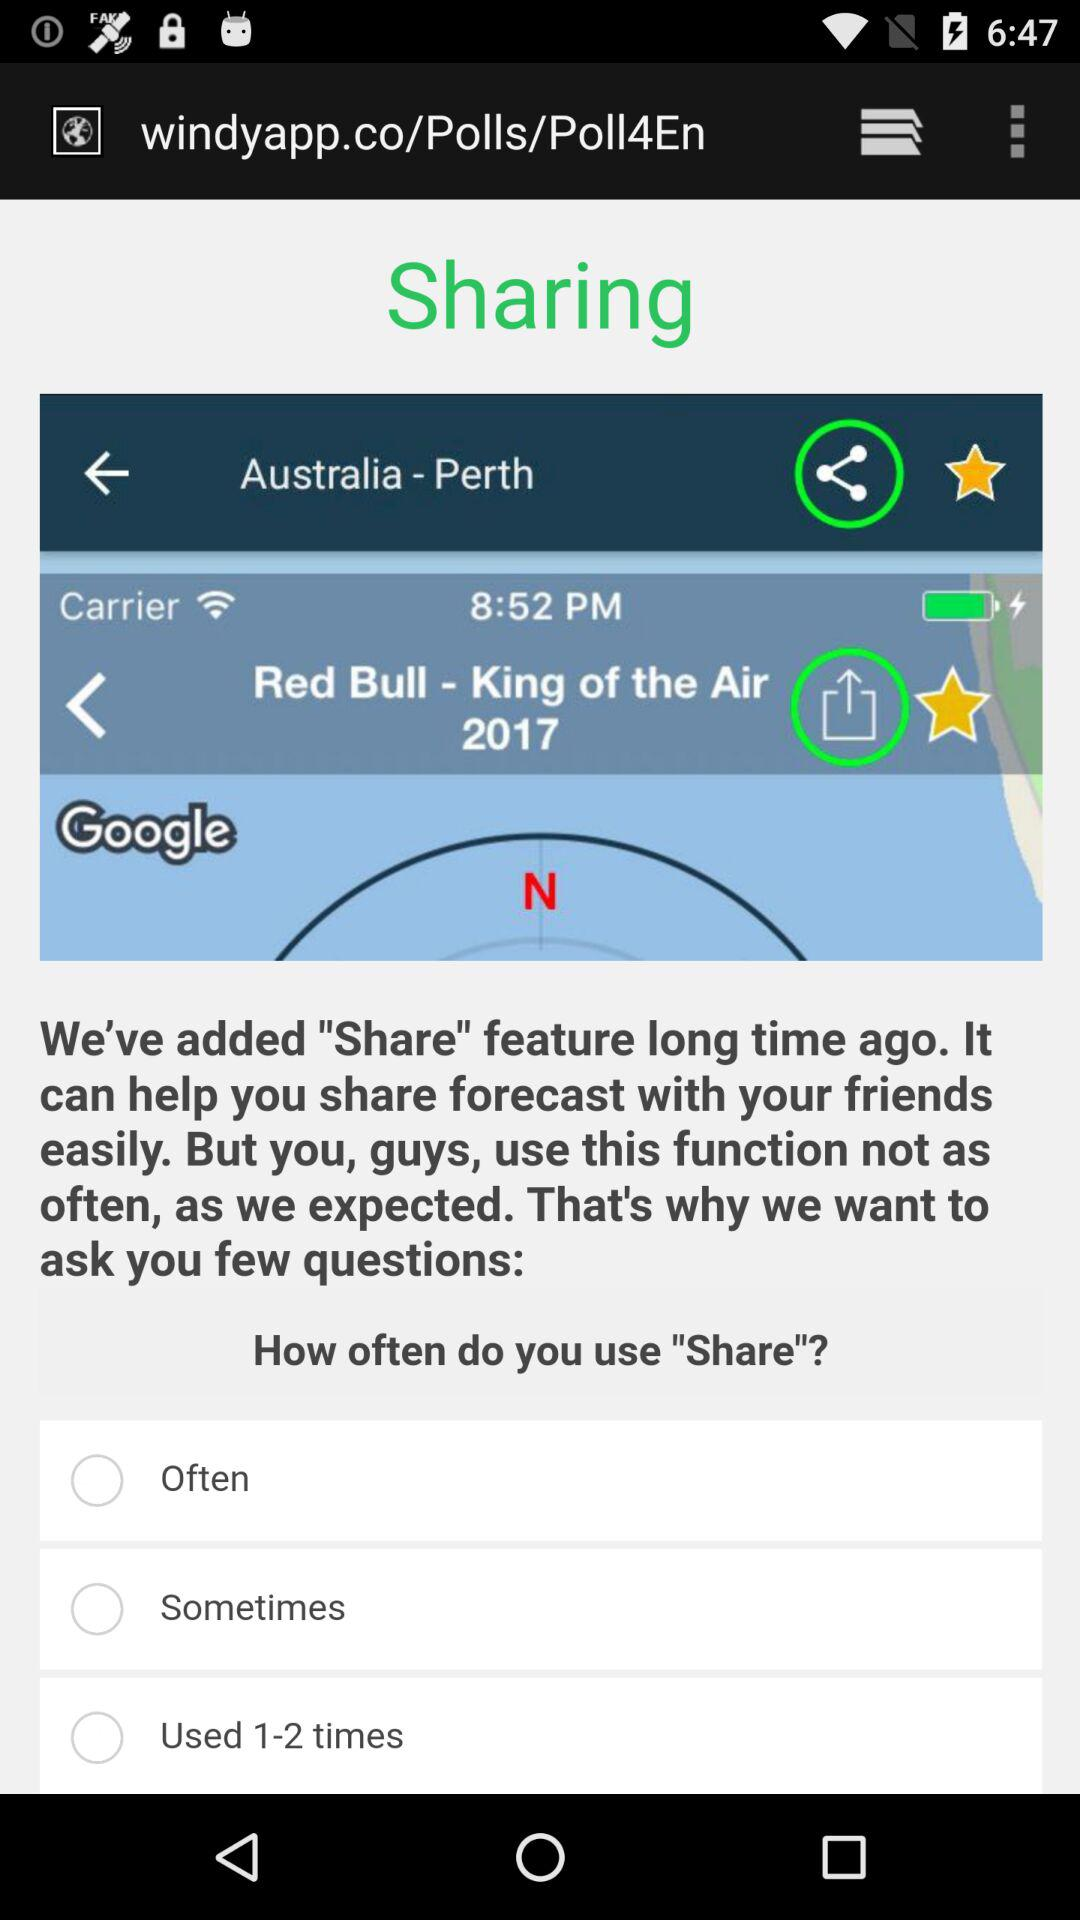What is the year? The year is 2017. 